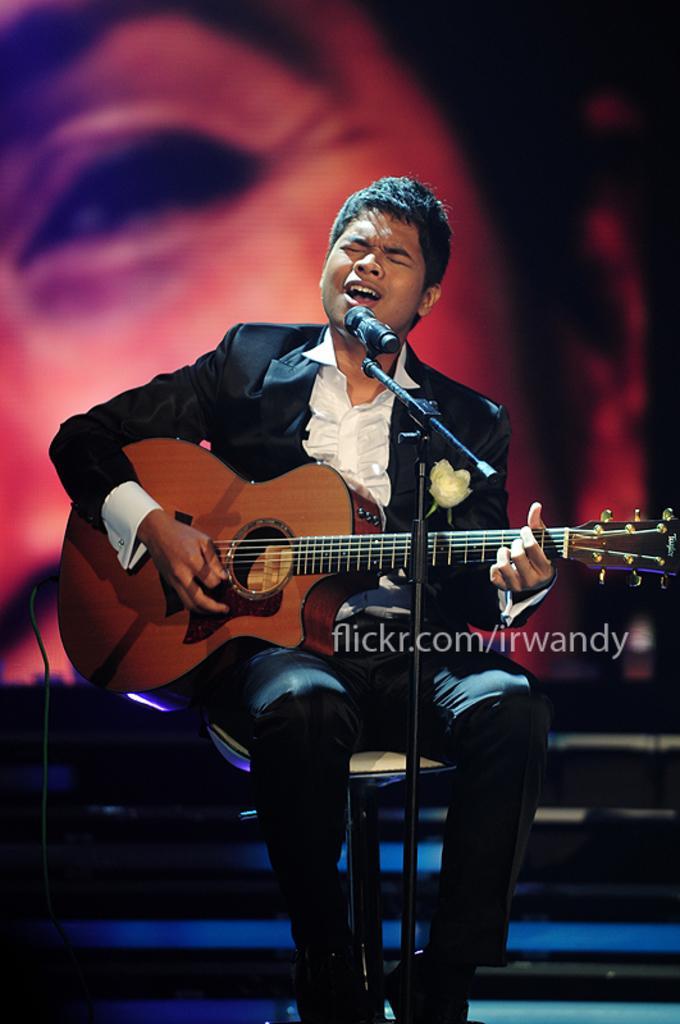How would you summarize this image in a sentence or two? This person sitting on the chair and playing guitar bad singing,in front of this person we can see microphone with stand. On the background we can see person face. 